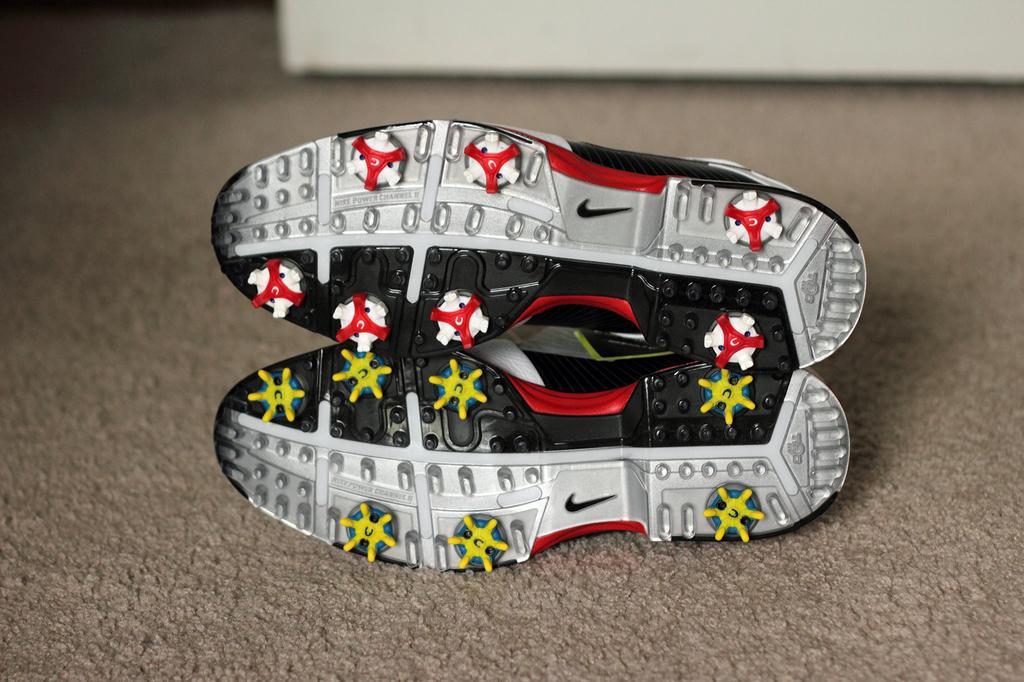How would you summarize this image in a sentence or two? In this image we can see shoes placed on the carpet. In the background there is an object. 